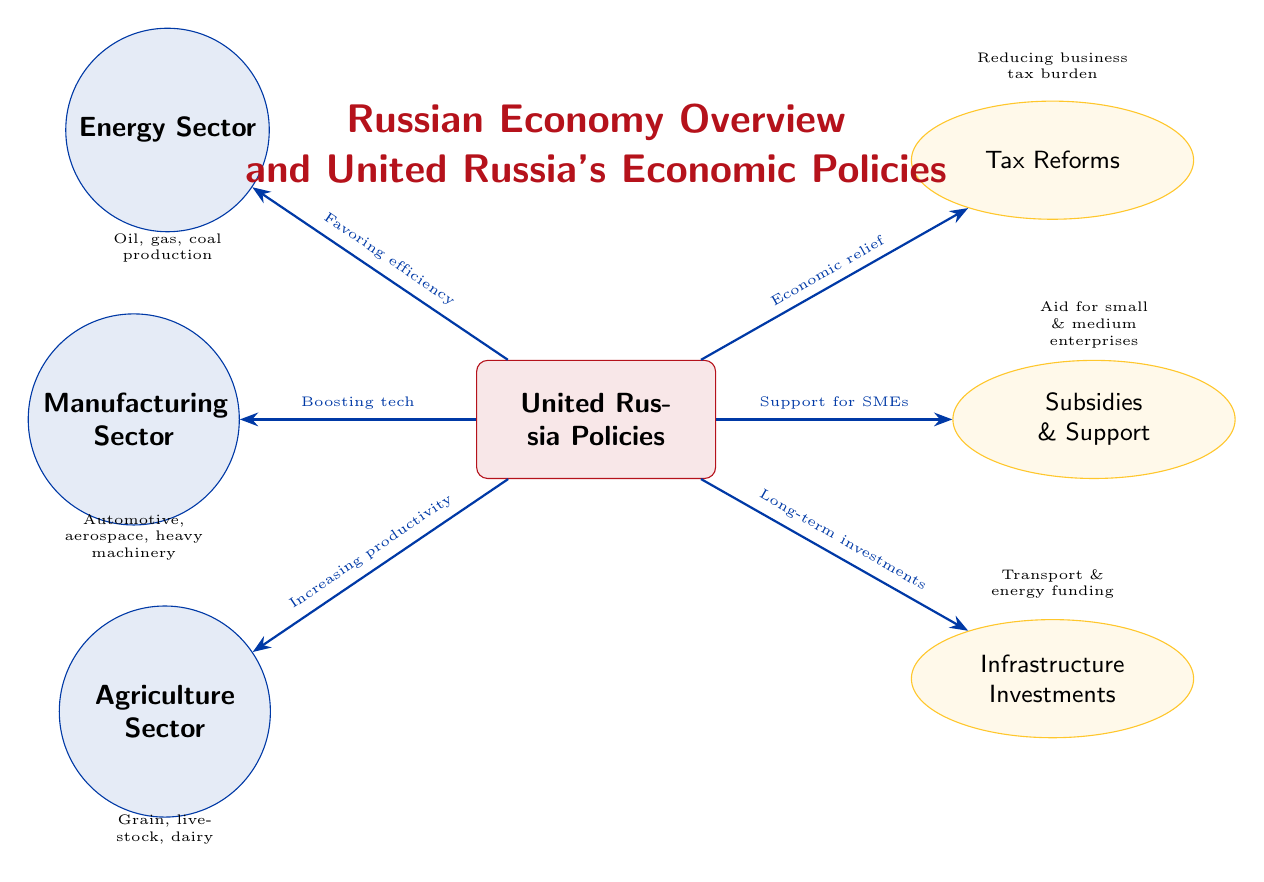What is the main focus of United Russia's policies? The main focus described in the diagram is "United Russia Policies," which is positioned as the central node of the diagram. This indicates that the policies stem from United Russia and influence various sectors in the economy.
Answer: United Russia Policies How many sectors are highlighted in the diagram? The diagram features three main sectors: Energy, Manufacturing, and Agriculture. Each sector is represented with a distinct circle node, indicating their significance in the economy.
Answer: Three What type of support is given for small and medium enterprises? The diagram states "Aid for small & medium enterprises" as the impact of the subsidies and support node, suggesting a direct connection to the policies aimed at encouraging these businesses.
Answer: Aid for small & medium enterprises Which sector focuses on automotive and aerospace production? The Manufacturing sector is highlighted as the sector focusing on "Automotive, aerospace, heavy machinery," indicating the types of production that take place within it.
Answer: Manufacturing Sector What is the purpose of the tax reforms mentioned? The diagram indicates "Reducing business tax burden" as the purpose of the tax reforms, which reflects United Russia’s intent to ease the financial pressure on businesses through these policies.
Answer: Reducing business tax burden Which sector benefits from infrastructure investments according to the diagram? Infrastructure investments impact all sectors indirectly, but there are no explicit connections showing this directly in the diagram. Given the wide-reaching nature of infrastructure, we can infer that multiple sectors benefit including energy and agriculture.
Answer: All sectors What are the long-term investments aimed at? The infrastructure investments node states "Transport & energy funding," indicating that these long-term investments are specifically targeted at enhancing transport and energy across various sectors.
Answer: Transport & energy funding What is the relationship between United Russia policies and the Energy sector? The diagram shows a direct relationship where United Russia's policies favor "efficiency," indicating a specific focus on enhancing operational efficiency within the energy sector.
Answer: Favoring efficiency 